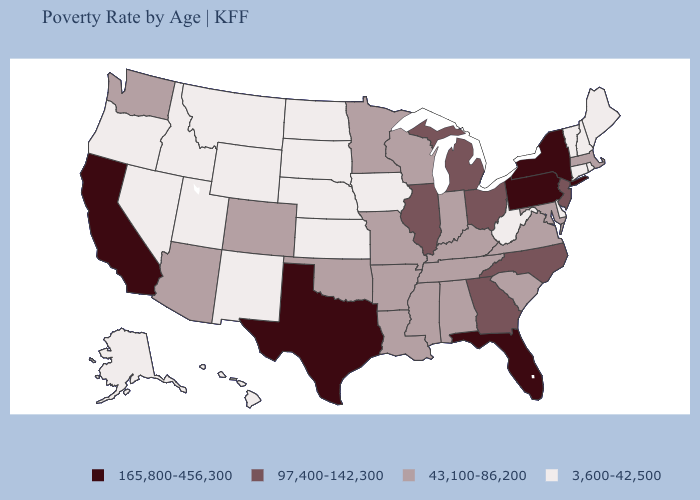What is the value of Mississippi?
Concise answer only. 43,100-86,200. Does Arizona have the lowest value in the USA?
Answer briefly. No. Does Minnesota have a higher value than Hawaii?
Quick response, please. Yes. What is the value of Oklahoma?
Write a very short answer. 43,100-86,200. Does South Carolina have the lowest value in the USA?
Short answer required. No. Does Idaho have the lowest value in the USA?
Write a very short answer. Yes. Does South Carolina have a lower value than New York?
Write a very short answer. Yes. What is the value of Colorado?
Write a very short answer. 43,100-86,200. What is the highest value in the Northeast ?
Keep it brief. 165,800-456,300. What is the value of Kentucky?
Quick response, please. 43,100-86,200. Name the states that have a value in the range 165,800-456,300?
Concise answer only. California, Florida, New York, Pennsylvania, Texas. What is the value of Missouri?
Be succinct. 43,100-86,200. Does Texas have the lowest value in the South?
Concise answer only. No. What is the highest value in the USA?
Concise answer only. 165,800-456,300. Does Maryland have the same value as Arkansas?
Keep it brief. Yes. 